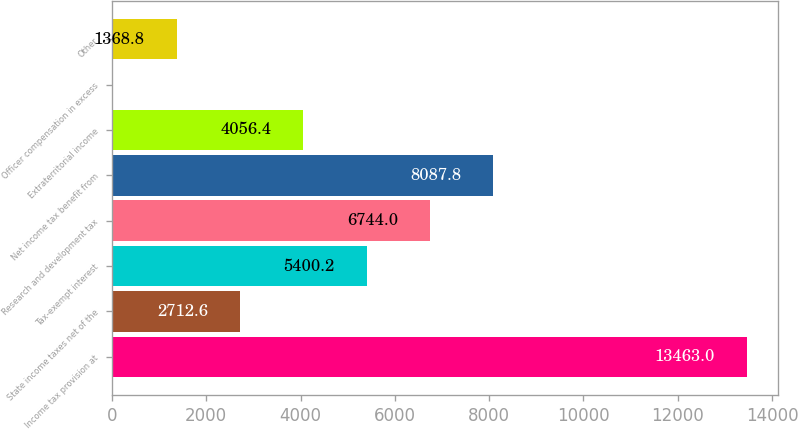Convert chart. <chart><loc_0><loc_0><loc_500><loc_500><bar_chart><fcel>Income tax provision at<fcel>State income taxes net of the<fcel>Tax-exempt interest<fcel>Research and development tax<fcel>Net income tax benefit from<fcel>Extraterritorial income<fcel>Officer compensation in excess<fcel>Other<nl><fcel>13463<fcel>2712.6<fcel>5400.2<fcel>6744<fcel>8087.8<fcel>4056.4<fcel>25<fcel>1368.8<nl></chart> 